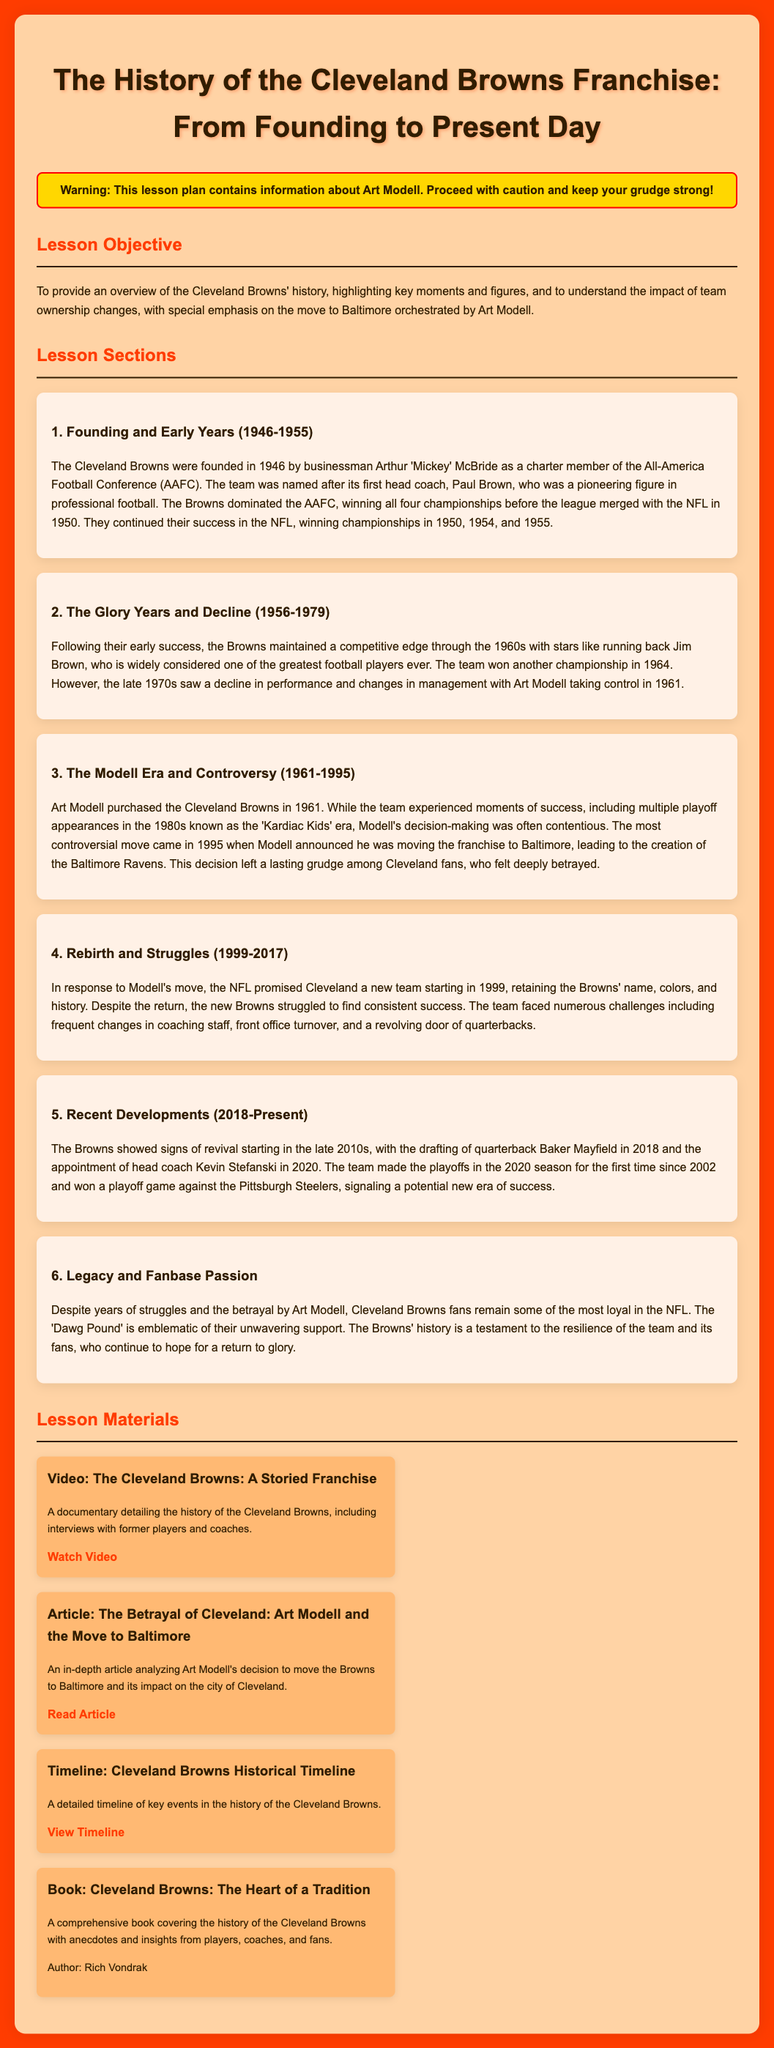What year were the Cleveland Browns founded? The founding year of the Cleveland Browns is mentioned in the document as 1946.
Answer: 1946 Who was the first head coach of the Cleveland Browns? The document states that the team was named after its first head coach, Paul Brown.
Answer: Paul Brown How many championships did the Browns win in the AAFC? The number of championships won by the Browns in the AAFC is specified as four.
Answer: four What significant move did Art Modell announce in 1995? The document highlights that Art Modell announced the move of the franchise to Baltimore in 1995.
Answer: move to Baltimore Which player is widely considered one of the greatest football players ever? The text mentions Jim Brown as a player widely considered among the greatest.
Answer: Jim Brown What was the nickname of the Browns’ era in the 1980s? The document refers to the 1980s era as the 'Kardiac Kids' era.
Answer: Kardiac Kids What year did the Browns return to the NFL? The return of the Browns to the NFL is noted as 1999.
Answer: 1999 Which quarterback was drafted by the Browns in 2018? The document states that Baker Mayfield was drafted by the Browns in 2018.
Answer: Baker Mayfield What is the name of the loyal fanbase of the Cleveland Browns? The fanbase is referred to as the 'Dawg Pound' in the document.
Answer: Dawg Pound 